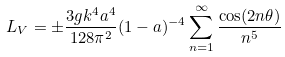<formula> <loc_0><loc_0><loc_500><loc_500>L _ { V } = \pm \frac { 3 g k ^ { 4 } a ^ { 4 } } { 1 2 8 \pi ^ { 2 } } ( 1 - a ) ^ { - 4 } \sum _ { n = 1 } ^ { \infty } \frac { \cos ( 2 n \theta ) } { n ^ { 5 } }</formula> 